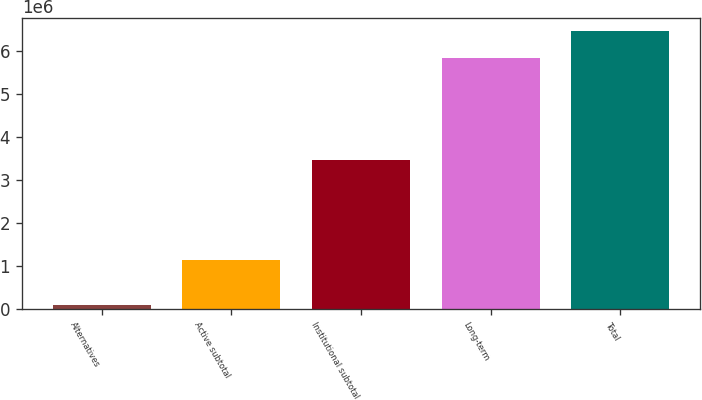Convert chart to OTSL. <chart><loc_0><loc_0><loc_500><loc_500><bar_chart><fcel>Alternatives<fcel>Active subtotal<fcel>Institutional subtotal<fcel>Long-term<fcel>Total<nl><fcel>84248<fcel>1.13931e+06<fcel>3.45612e+06<fcel>5.83673e+06<fcel>6.45713e+06<nl></chart> 